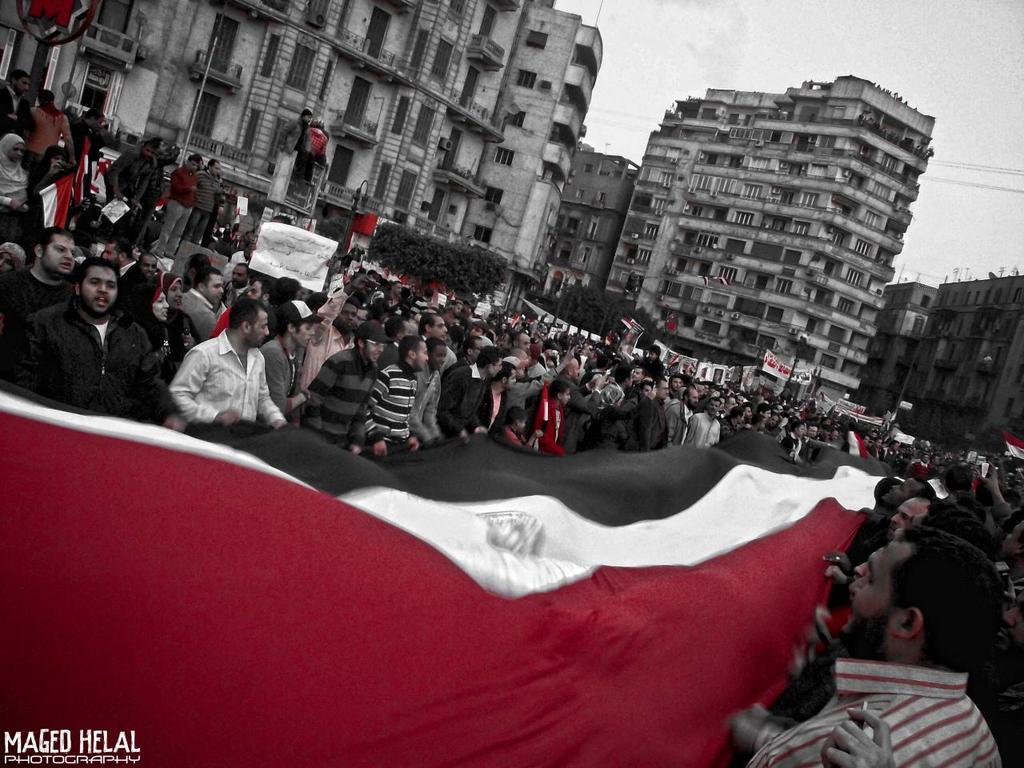How many people are present in the image? There are many people in the image. What are the people holding in the image? The people are holding a flag. What can be seen in the background of the image? There are buildings in the background of the image. What is visible at the top of the image? The sky is visible at the top of the image. What type of soda is being served at the event in the image? There is no event or soda present in the image; it features a group of people holding a flag. What subject is the person teaching in the image? There is no person teaching in the image; it shows a group of people holding a flag. 